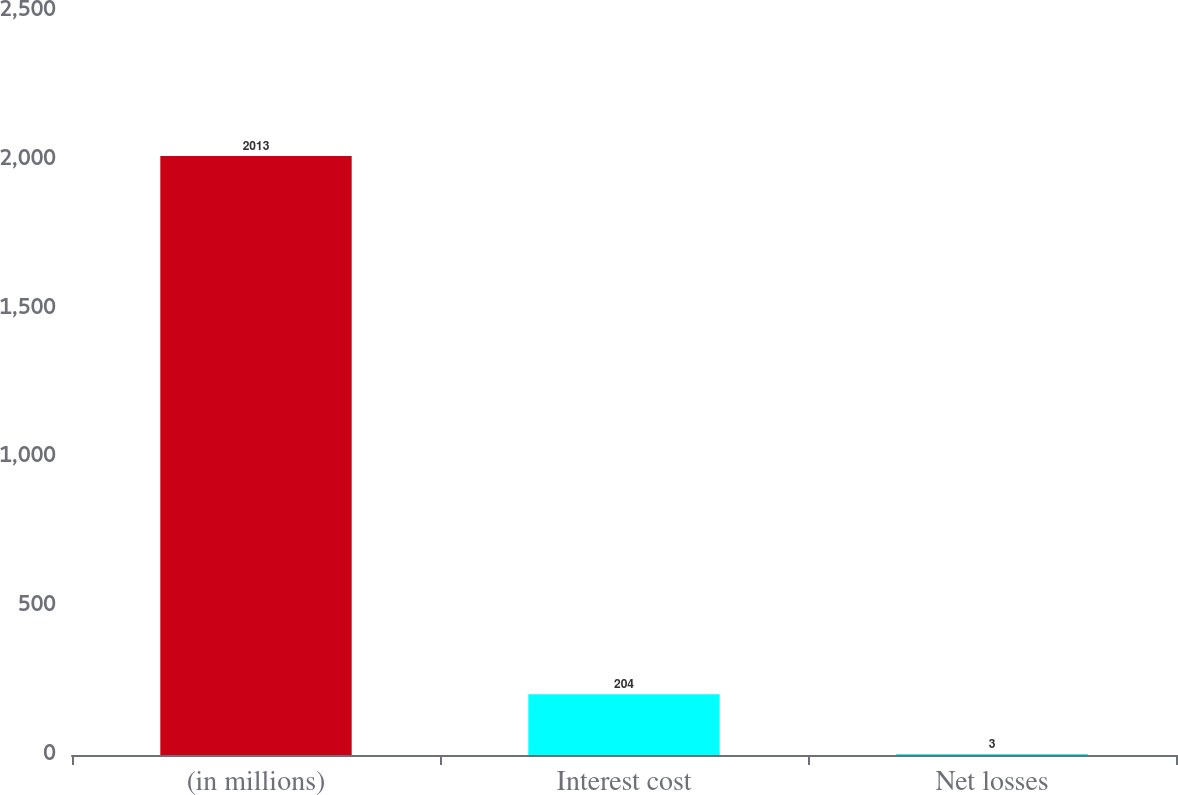<chart> <loc_0><loc_0><loc_500><loc_500><bar_chart><fcel>(in millions)<fcel>Interest cost<fcel>Net losses<nl><fcel>2013<fcel>204<fcel>3<nl></chart> 